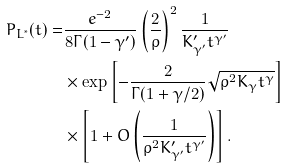Convert formula to latex. <formula><loc_0><loc_0><loc_500><loc_500>P _ { L ^ { * } } ( t ) = & \frac { e ^ { - 2 } } { 8 \Gamma ( 1 - \gamma ^ { \prime } ) } \left ( \frac { 2 } { \rho } \right ) ^ { 2 } \frac { 1 } { K ^ { \prime } _ { \gamma ^ { \prime } } t ^ { \gamma ^ { \prime } } } \\ & \times \exp \left [ - \frac { 2 } { \Gamma ( 1 + \gamma / 2 ) } \sqrt { \rho ^ { 2 } K _ { \gamma } t ^ { \gamma } } \right ] \\ & \times \left [ 1 + O \left ( \frac { 1 } { \rho ^ { 2 } K ^ { \prime } _ { \gamma ^ { \prime } } t ^ { \gamma ^ { \prime } } } \right ) \right ] .</formula> 